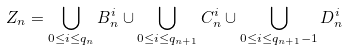Convert formula to latex. <formula><loc_0><loc_0><loc_500><loc_500>Z _ { n } = \bigcup _ { 0 \leq i \leq q _ { n } } B _ { n } ^ { i } \cup \bigcup _ { 0 \leq i \leq q _ { n + 1 } } C _ { n } ^ { i } \cup \bigcup _ { 0 \leq i \leq q _ { n + 1 } - 1 } D _ { n } ^ { i }</formula> 